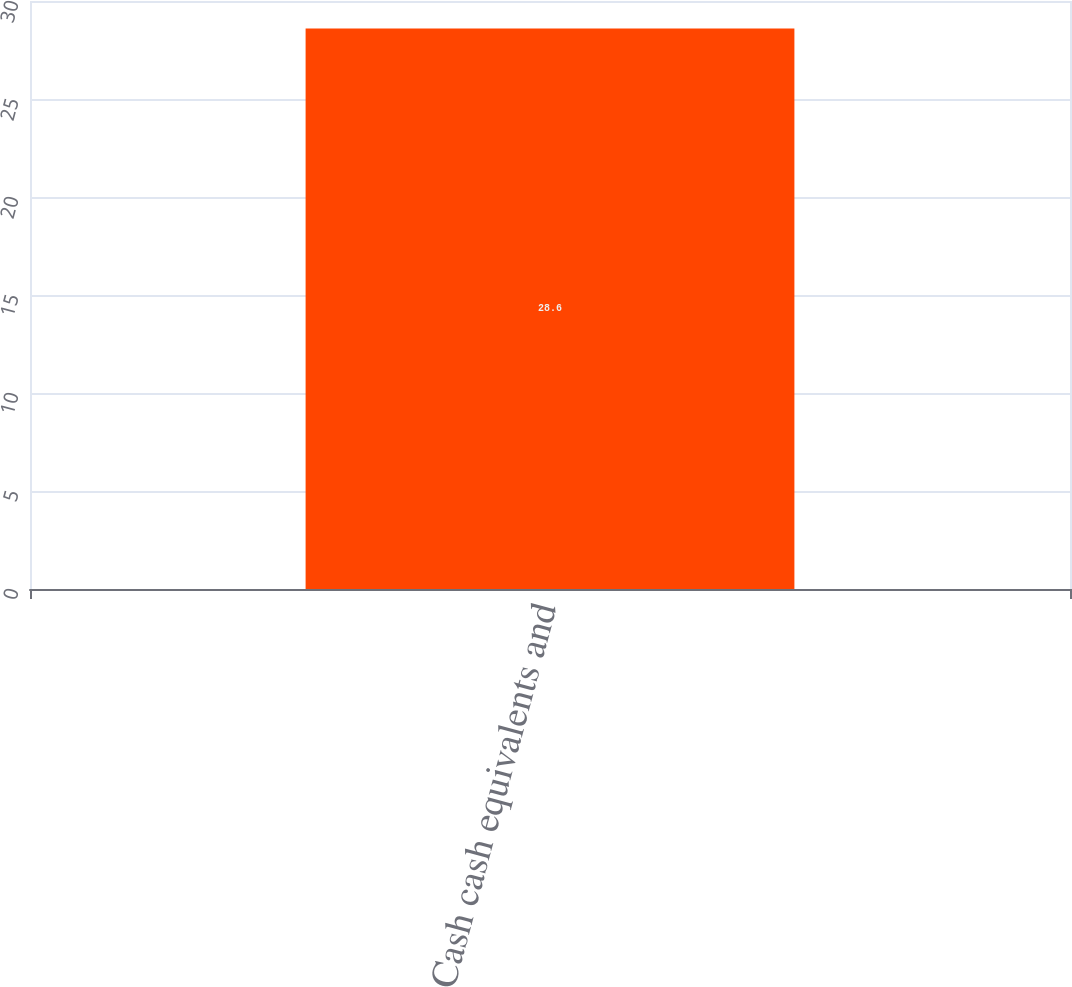<chart> <loc_0><loc_0><loc_500><loc_500><bar_chart><fcel>Cash cash equivalents and<nl><fcel>28.6<nl></chart> 